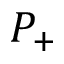Convert formula to latex. <formula><loc_0><loc_0><loc_500><loc_500>P _ { + }</formula> 